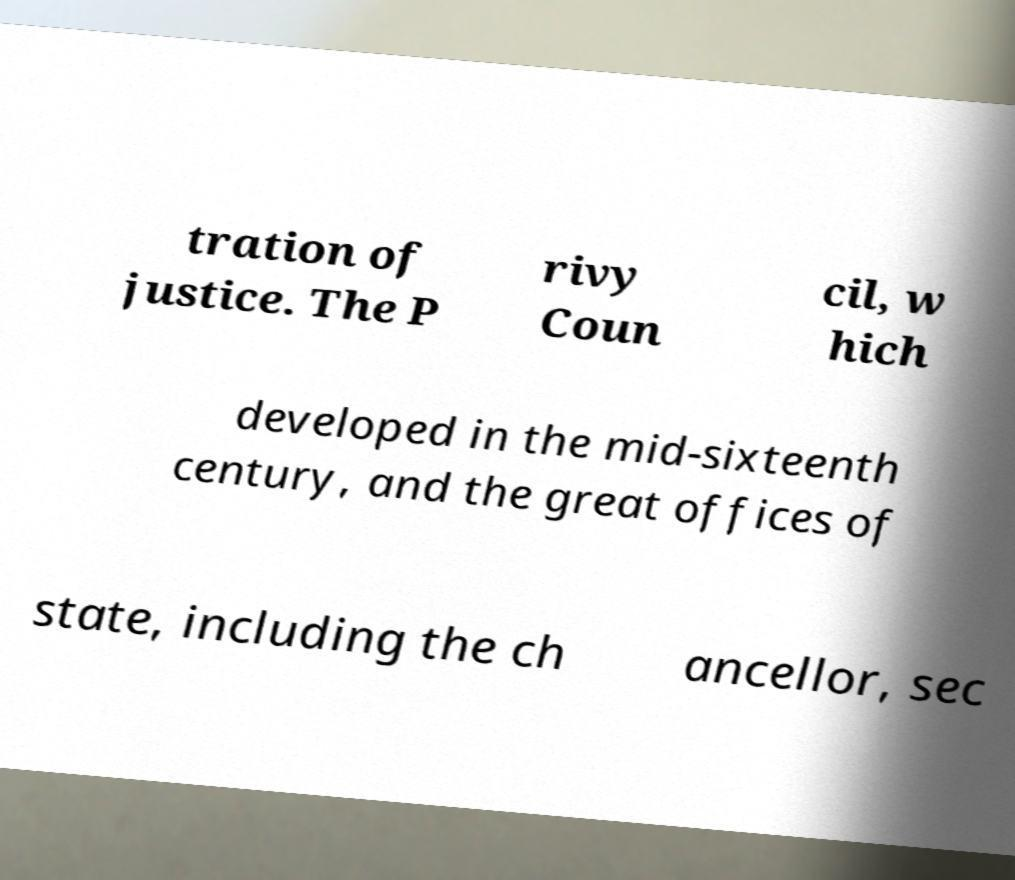Could you extract and type out the text from this image? tration of justice. The P rivy Coun cil, w hich developed in the mid-sixteenth century, and the great offices of state, including the ch ancellor, sec 